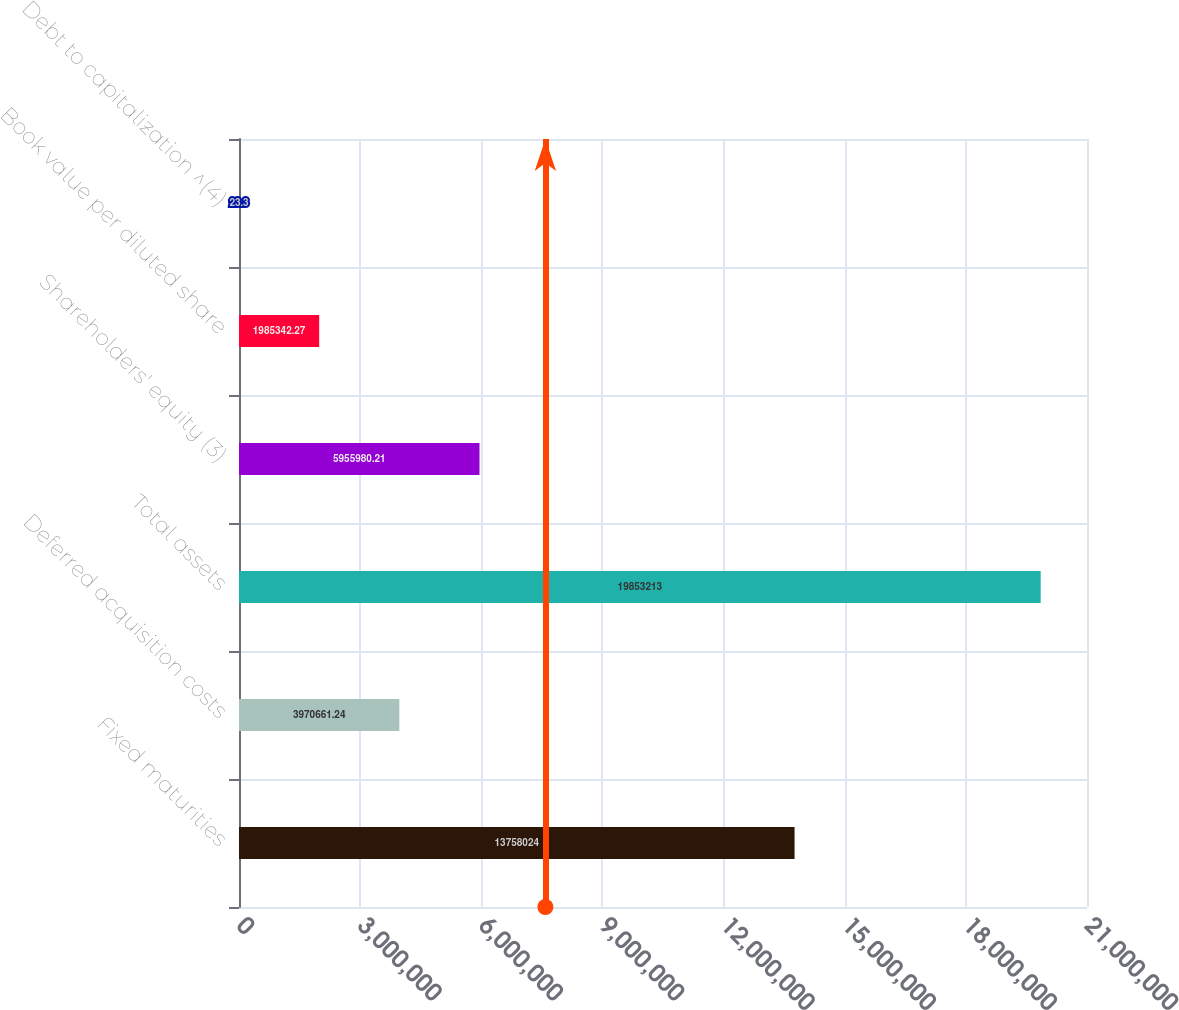Convert chart. <chart><loc_0><loc_0><loc_500><loc_500><bar_chart><fcel>Fixed maturities<fcel>Deferred acquisition costs<fcel>Total assets<fcel>Shareholders' equity (3)<fcel>Book value per diluted share<fcel>Debt to capitalization ^(4)<nl><fcel>1.3758e+07<fcel>3.97066e+06<fcel>1.98532e+07<fcel>5.95598e+06<fcel>1.98534e+06<fcel>23.3<nl></chart> 